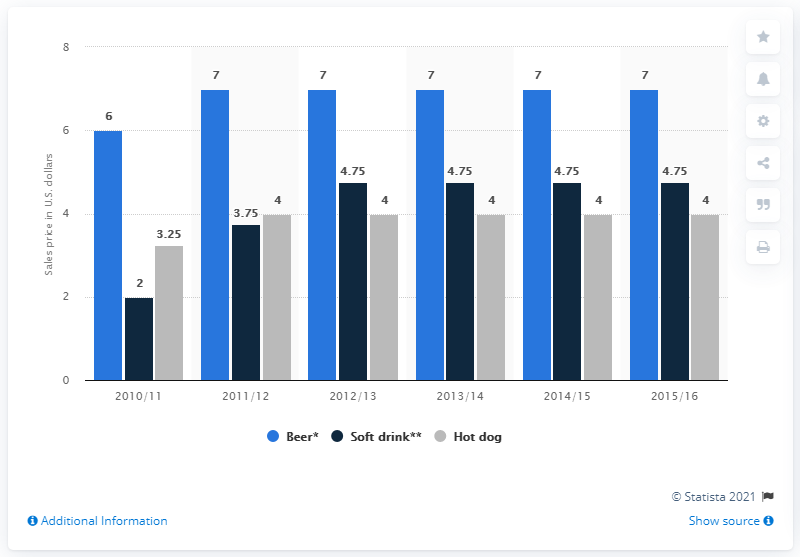Indicate a few pertinent items in this graphic. The highest concession stand prices for beer at Sacramento Kings games from the 2010/11 season to the 2015/16 season ranged from $7 to $8.50, with an average price of $7.50 per beer. The difference between the shortest light blue bar and the tallest dark blue bar is 1.25. 